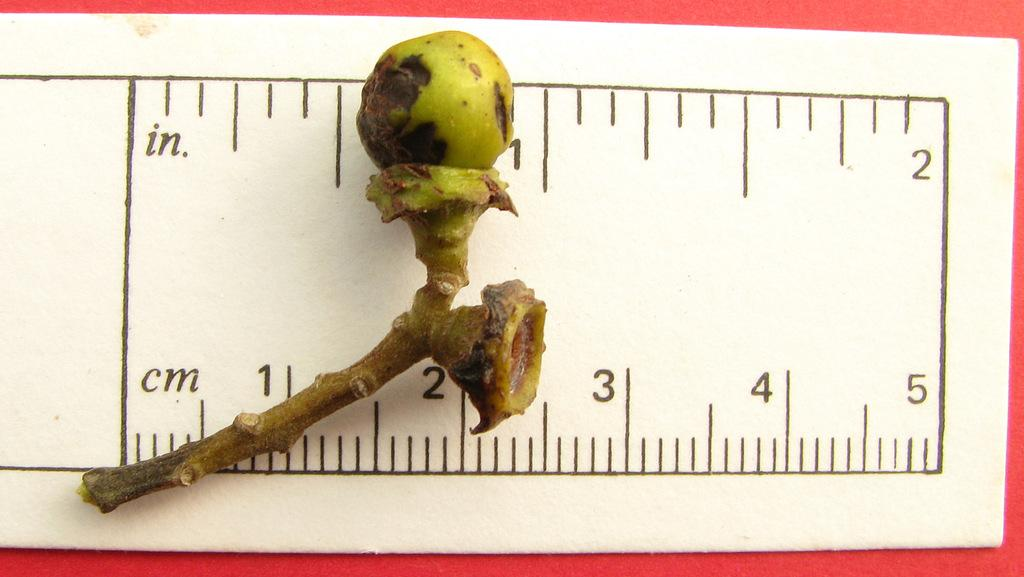<image>
Summarize the visual content of the image. a ruler measuing a small object in either inches or cm 